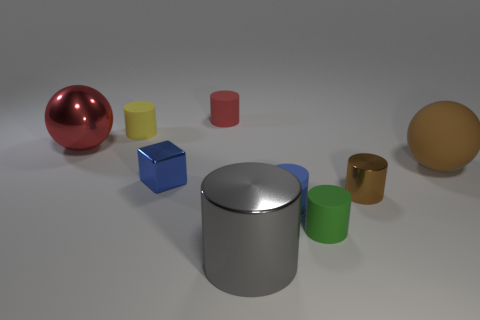Is the tiny brown thing the same shape as the gray shiny thing? The tiny brown object appears to be cylindrical, similar to the larger gray cylinder in the center of the image. Both share a circular base and elongated sides, which makes them look similar in shape, albeit different in size and texture. 